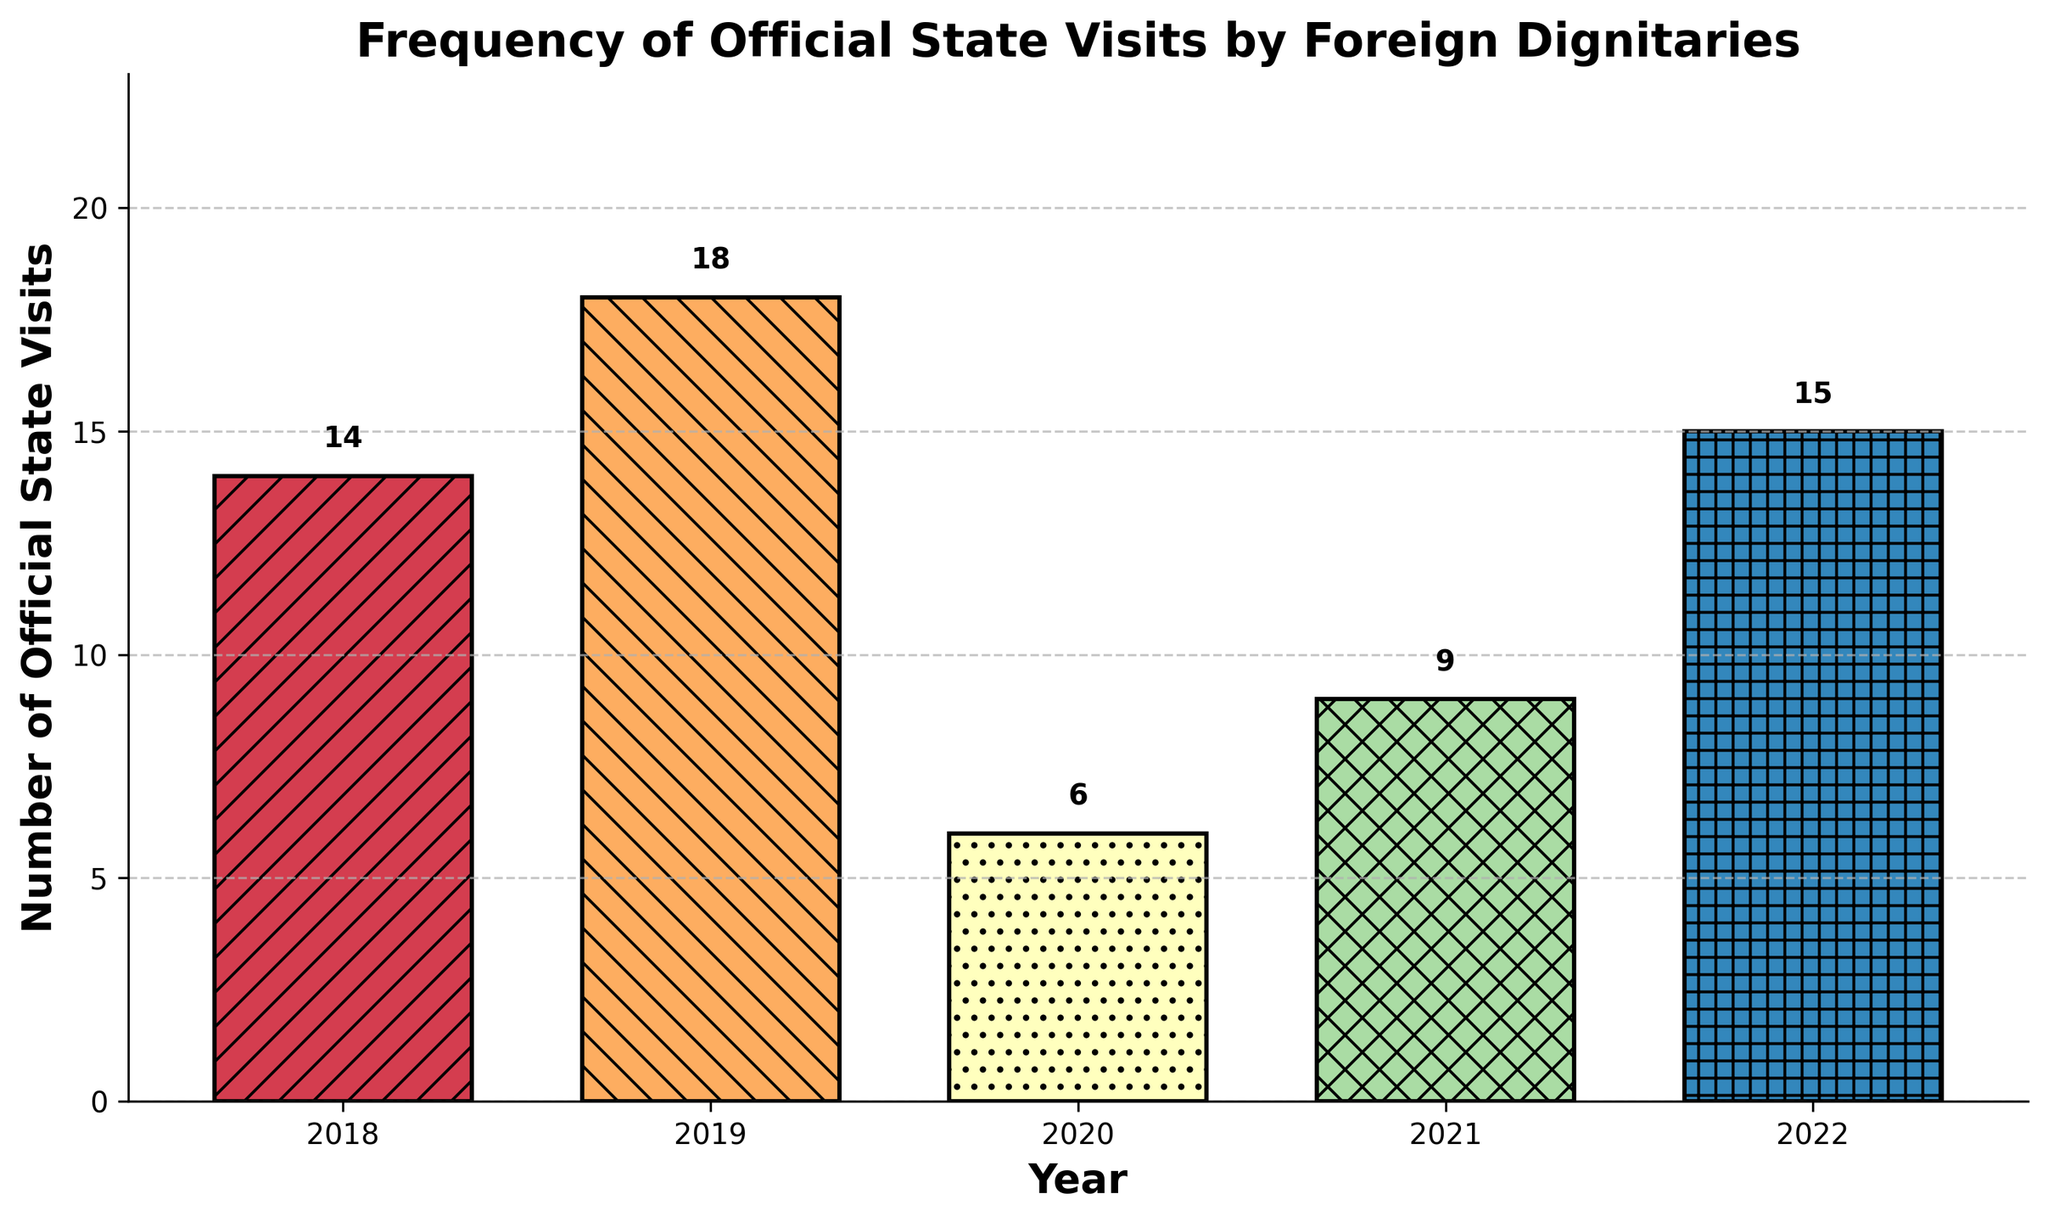what is the total number of official state visits from 2018 to 2022? Sum the number of visits for each year: 14 (2018) + 18 (2019) + 6 (2020) + 9 (2021) + 15 (2022) = 62
Answer: 62 Which year had the highest number of official state visits? Identify the year with the tallest bar in the chart. 2019 has the highest bar, corresponding to 18 visits
Answer: 2019 What is the difference in the number of visits between the years with the highest and lowest state visits? First, find the highest number of visits (18 in 2019) and the lowest number of visits (6 in 2020). Then, subtract the lowest from the highest: 18 - 6 = 12
Answer: 12 How does the number of visits in 2021 compare to 2020? Compare the heights of the bars for 2021 and 2020. 2021 (9 visits) has more visits than 2020 (6 visits)
Answer: 2021 had more visits than 2020 Which year had a notable increase in visits following a year with lower visits? Look for a steep rise in bar height from one year to the next. From 2021 to 2022, the number of visits increased from 9 to 15
Answer: 2022 What is the average number of official state visits per year over the last 5 years? Sum the total visits (62) and divide by the number of years (5): 62 / 5 = 12.4
Answer: 12.4 If the trend from 2020 to 2021 continued into 2023, how many visits would you expect in 2023? From 2020 to 2021, visits increased by 3 (9 - 6). If this upward trend continued, the number of visits in 2023 would be approximately 15 (12 + 3)
Answer: 12 